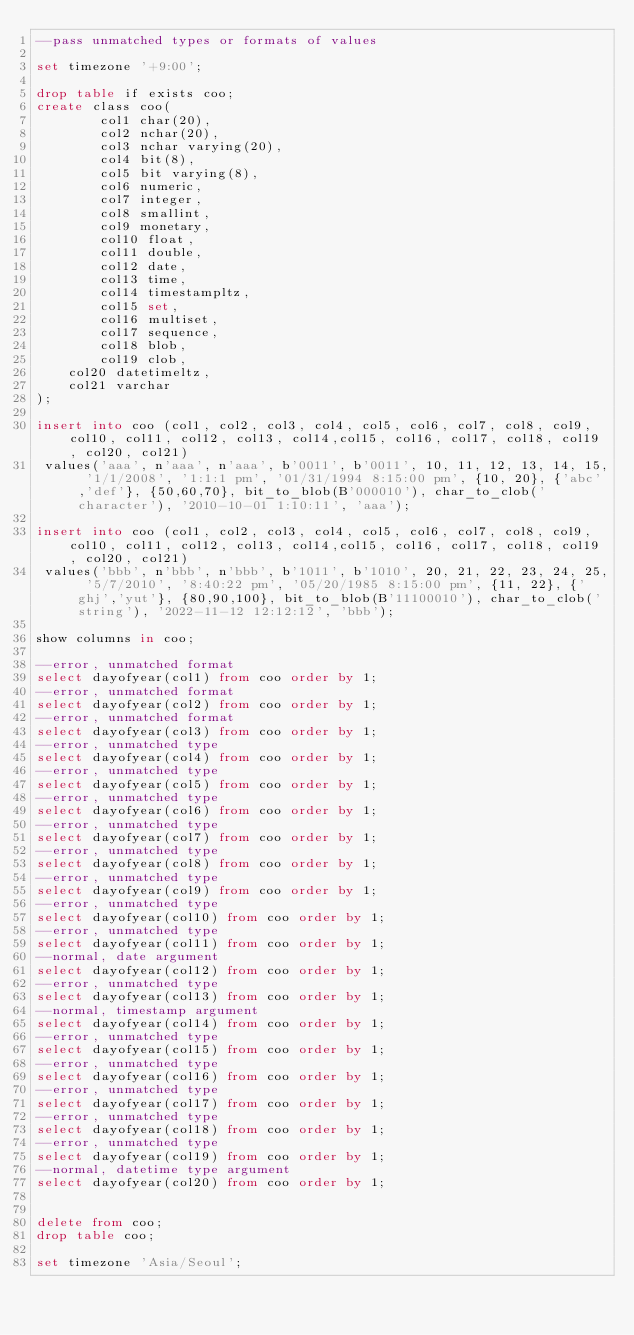Convert code to text. <code><loc_0><loc_0><loc_500><loc_500><_SQL_>--pass unmatched types or formats of values

set timezone '+9:00';

drop table if exists coo;
create class coo(
        col1 char(20),
        col2 nchar(20),
        col3 nchar varying(20),
        col4 bit(8),
        col5 bit varying(8),
        col6 numeric,
        col7 integer,
        col8 smallint,
        col9 monetary,
        col10 float,
        col11 double,
        col12 date,
        col13 time,
        col14 timestampltz,
        col15 set,
        col16 multiset,
        col17 sequence,
        col18 blob,
        col19 clob,
		col20 datetimeltz,
		col21 varchar
);

insert into coo (col1, col2, col3, col4, col5, col6, col7, col8, col9, col10, col11, col12, col13, col14,col15, col16, col17, col18, col19, col20, col21)
 values('aaa', n'aaa', n'aaa', b'0011', b'0011', 10, 11, 12, 13, 14, 15, '1/1/2008', '1:1:1 pm', '01/31/1994 8:15:00 pm', {10, 20}, {'abc','def'}, {50,60,70}, bit_to_blob(B'000010'), char_to_clob('character'), '2010-10-01 1:10:11', 'aaa');

insert into coo (col1, col2, col3, col4, col5, col6, col7, col8, col9, col10, col11, col12, col13, col14,col15, col16, col17, col18, col19, col20, col21)
 values('bbb', n'bbb', n'bbb', b'1011', b'1010', 20, 21, 22, 23, 24, 25, '5/7/2010', '8:40:22 pm', '05/20/1985 8:15:00 pm', {11, 22}, {'ghj','yut'}, {80,90,100}, bit_to_blob(B'11100010'), char_to_clob('string'), '2022-11-12 12:12:12', 'bbb');

show columns in coo;

--error, unmatched format
select dayofyear(col1) from coo order by 1;
--error, unmatched format
select dayofyear(col2) from coo order by 1;
--error, unmatched format
select dayofyear(col3) from coo order by 1;
--error, unmatched type
select dayofyear(col4) from coo order by 1;
--error, unmatched type
select dayofyear(col5) from coo order by 1;
--error, unmatched type
select dayofyear(col6) from coo order by 1;
--error, unmatched type
select dayofyear(col7) from coo order by 1;
--error, unmatched type
select dayofyear(col8) from coo order by 1;
--error, unmatched type
select dayofyear(col9) from coo order by 1;
--error, unmatched type
select dayofyear(col10) from coo order by 1;
--error, unmatched type
select dayofyear(col11) from coo order by 1;
--normal, date argument
select dayofyear(col12) from coo order by 1;
--error, unmatched type
select dayofyear(col13) from coo order by 1;
--normal, timestamp argument
select dayofyear(col14) from coo order by 1;
--error, unmatched type
select dayofyear(col15) from coo order by 1;
--error, unmatched type
select dayofyear(col16) from coo order by 1;
--error, unmatched type
select dayofyear(col17) from coo order by 1;
--error, unmatched type
select dayofyear(col18) from coo order by 1;
--error, unmatched type
select dayofyear(col19) from coo order by 1;
--normal, datetime type argument
select dayofyear(col20) from coo order by 1;


delete from coo;
drop table coo;

set timezone 'Asia/Seoul';
</code> 